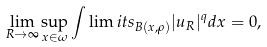Convert formula to latex. <formula><loc_0><loc_0><loc_500><loc_500>\lim _ { R \to \infty } \sup _ { x \in \omega } { \int \lim i t s _ { B ( x , \rho ) } | u _ { R } | ^ { q } d x } = 0 ,</formula> 